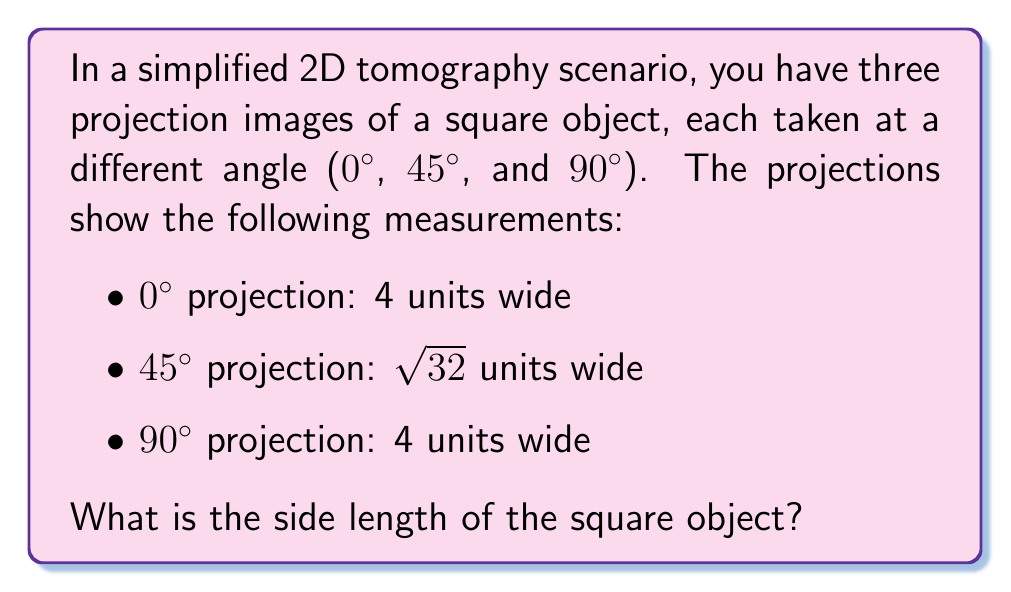Teach me how to tackle this problem. Let's approach this step-by-step:

1) First, we need to understand what each projection represents:
   - The 0° and 90° projections show the width of the square directly.
   - The 45° projection shows the diagonal of the square.

2) From the 0° and 90° projections, we know that the square has a width of 4 units.

3) To confirm this, we can use the 45° projection:
   - In a square, the diagonal forms a 45-45-90 triangle with two sides.
   - In a 45-45-90 triangle, the diagonal is $\sqrt{2}$ times the side length.

4) Let's call the side length of the square $s$. Then:
   
   $s\sqrt{2} = \sqrt{32}$

5) Solving for $s$:
   
   $s = \frac{\sqrt{32}}{\sqrt{2}} = \sqrt{16} = 4$

6) This confirms our initial observation from the 0° and 90° projections.

Therefore, the reconstructed square object has a side length of 4 units.
Answer: 4 units 